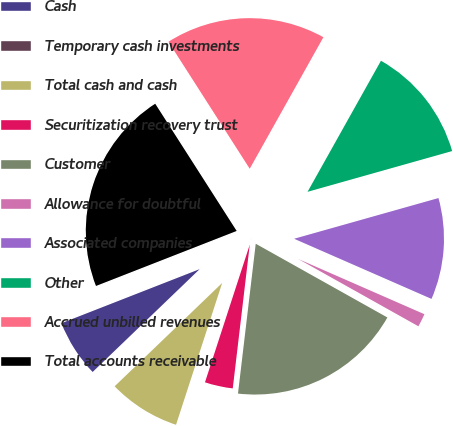<chart> <loc_0><loc_0><loc_500><loc_500><pie_chart><fcel>Cash<fcel>Temporary cash investments<fcel>Total cash and cash<fcel>Securitization recovery trust<fcel>Customer<fcel>Allowance for doubtful<fcel>Associated companies<fcel>Other<fcel>Accrued unbilled revenues<fcel>Total accounts receivable<nl><fcel>6.25%<fcel>0.0%<fcel>7.81%<fcel>3.13%<fcel>18.75%<fcel>1.56%<fcel>10.94%<fcel>12.5%<fcel>17.19%<fcel>21.87%<nl></chart> 